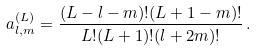Convert formula to latex. <formula><loc_0><loc_0><loc_500><loc_500>a ^ { ( L ) } _ { l , m } = \frac { ( L - l - m ) ! ( L + 1 - m ) ! } { L ! ( L + 1 ) ! ( l + 2 m ) ! } \, .</formula> 